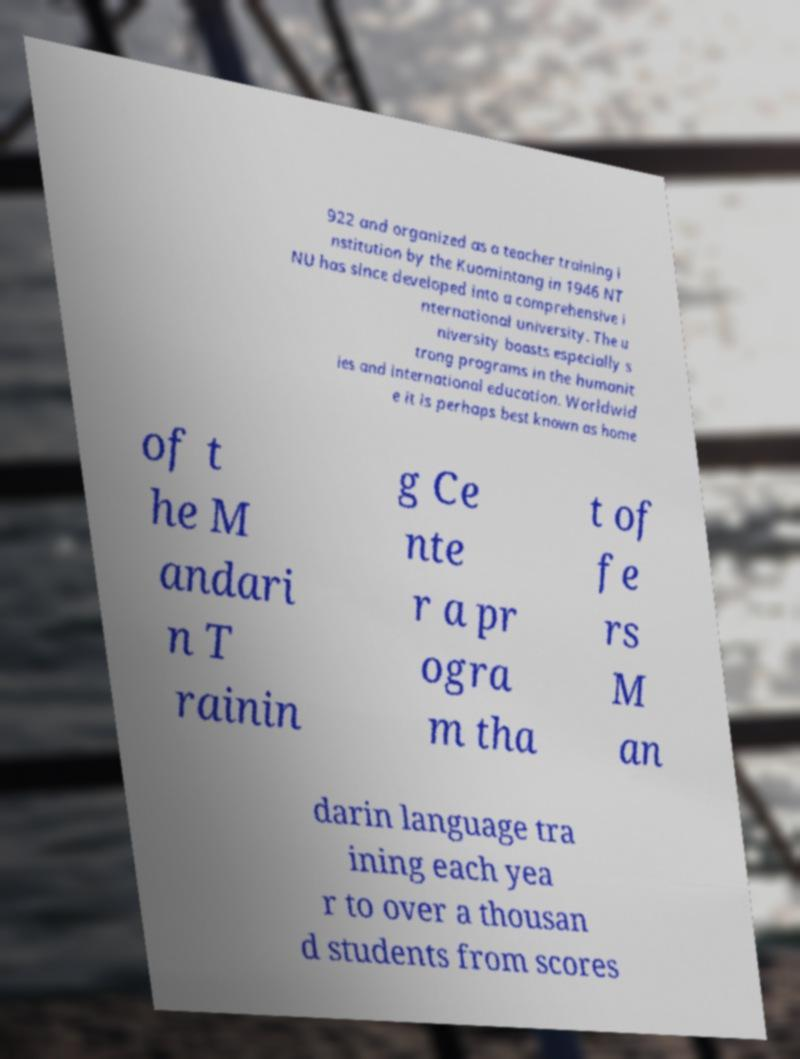I need the written content from this picture converted into text. Can you do that? 922 and organized as a teacher training i nstitution by the Kuomintang in 1946 NT NU has since developed into a comprehensive i nternational university. The u niversity boasts especially s trong programs in the humanit ies and international education. Worldwid e it is perhaps best known as home of t he M andari n T rainin g Ce nte r a pr ogra m tha t of fe rs M an darin language tra ining each yea r to over a thousan d students from scores 